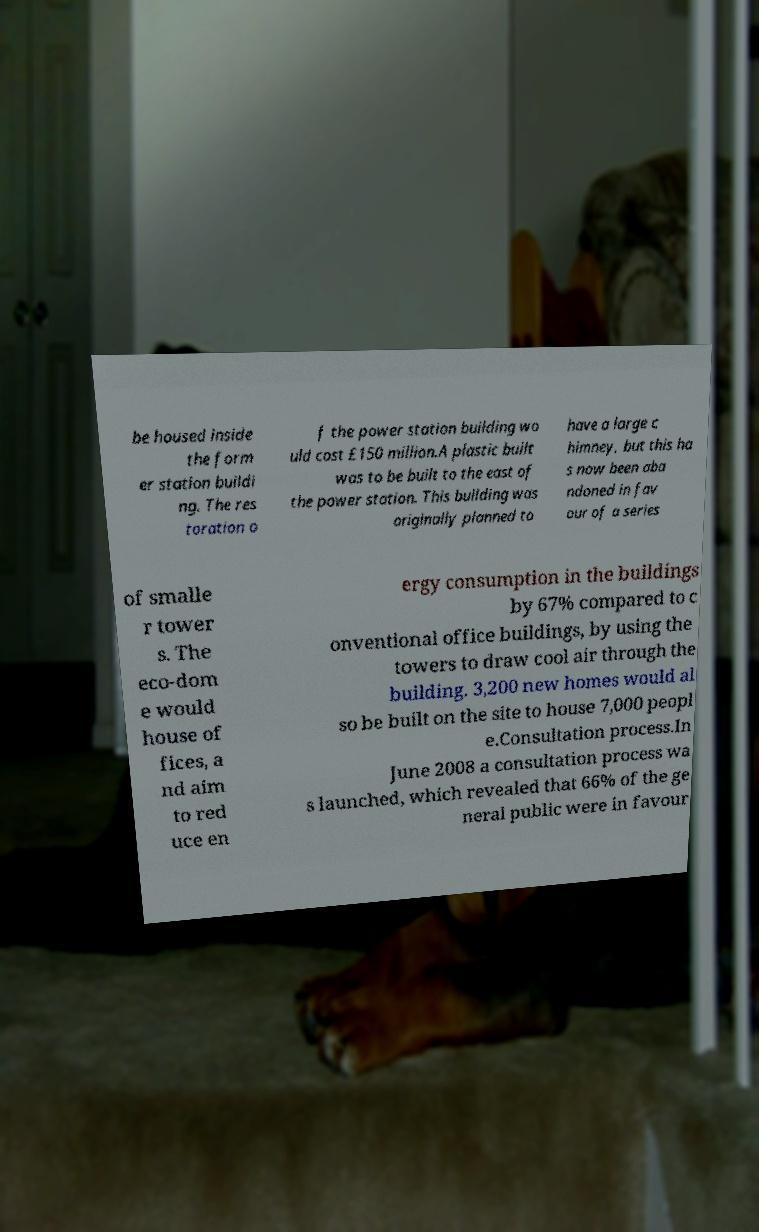What messages or text are displayed in this image? I need them in a readable, typed format. be housed inside the form er station buildi ng. The res toration o f the power station building wo uld cost £150 million.A plastic built was to be built to the east of the power station. This building was originally planned to have a large c himney, but this ha s now been aba ndoned in fav our of a series of smalle r tower s. The eco-dom e would house of fices, a nd aim to red uce en ergy consumption in the buildings by 67% compared to c onventional office buildings, by using the towers to draw cool air through the building. 3,200 new homes would al so be built on the site to house 7,000 peopl e.Consultation process.In June 2008 a consultation process wa s launched, which revealed that 66% of the ge neral public were in favour 